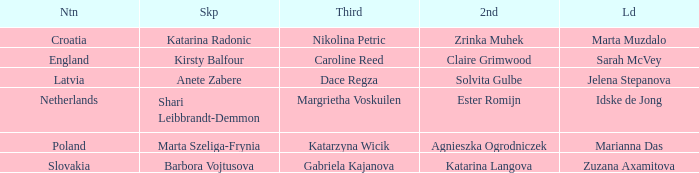Which skip has Zrinka Muhek as Second? Katarina Radonic. 